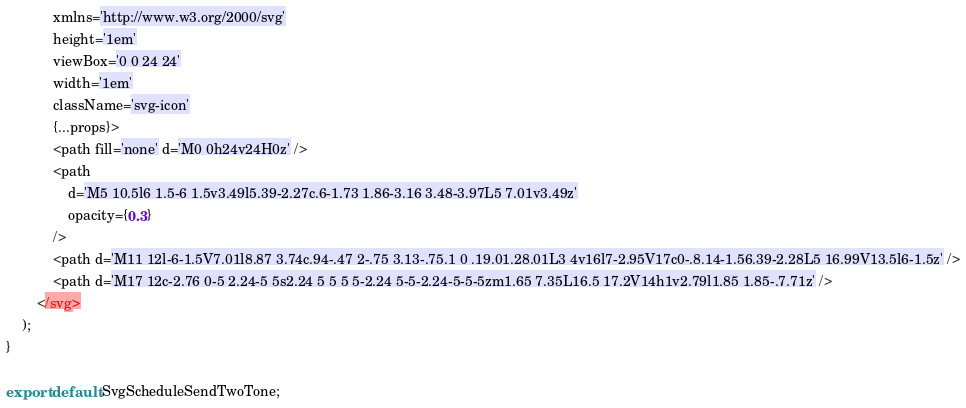Convert code to text. <code><loc_0><loc_0><loc_500><loc_500><_JavaScript_>			xmlns='http://www.w3.org/2000/svg'
			height='1em'
			viewBox='0 0 24 24'
			width='1em'
			className='svg-icon'
			{...props}>
			<path fill='none' d='M0 0h24v24H0z' />
			<path
				d='M5 10.5l6 1.5-6 1.5v3.49l5.39-2.27c.6-1.73 1.86-3.16 3.48-3.97L5 7.01v3.49z'
				opacity={0.3}
			/>
			<path d='M11 12l-6-1.5V7.01l8.87 3.74c.94-.47 2-.75 3.13-.75.1 0 .19.01.28.01L3 4v16l7-2.95V17c0-.8.14-1.56.39-2.28L5 16.99V13.5l6-1.5z' />
			<path d='M17 12c-2.76 0-5 2.24-5 5s2.24 5 5 5 5-2.24 5-5-2.24-5-5-5zm1.65 7.35L16.5 17.2V14h1v2.79l1.85 1.85-.7.71z' />
		</svg>
	);
}

export default SvgScheduleSendTwoTone;
</code> 